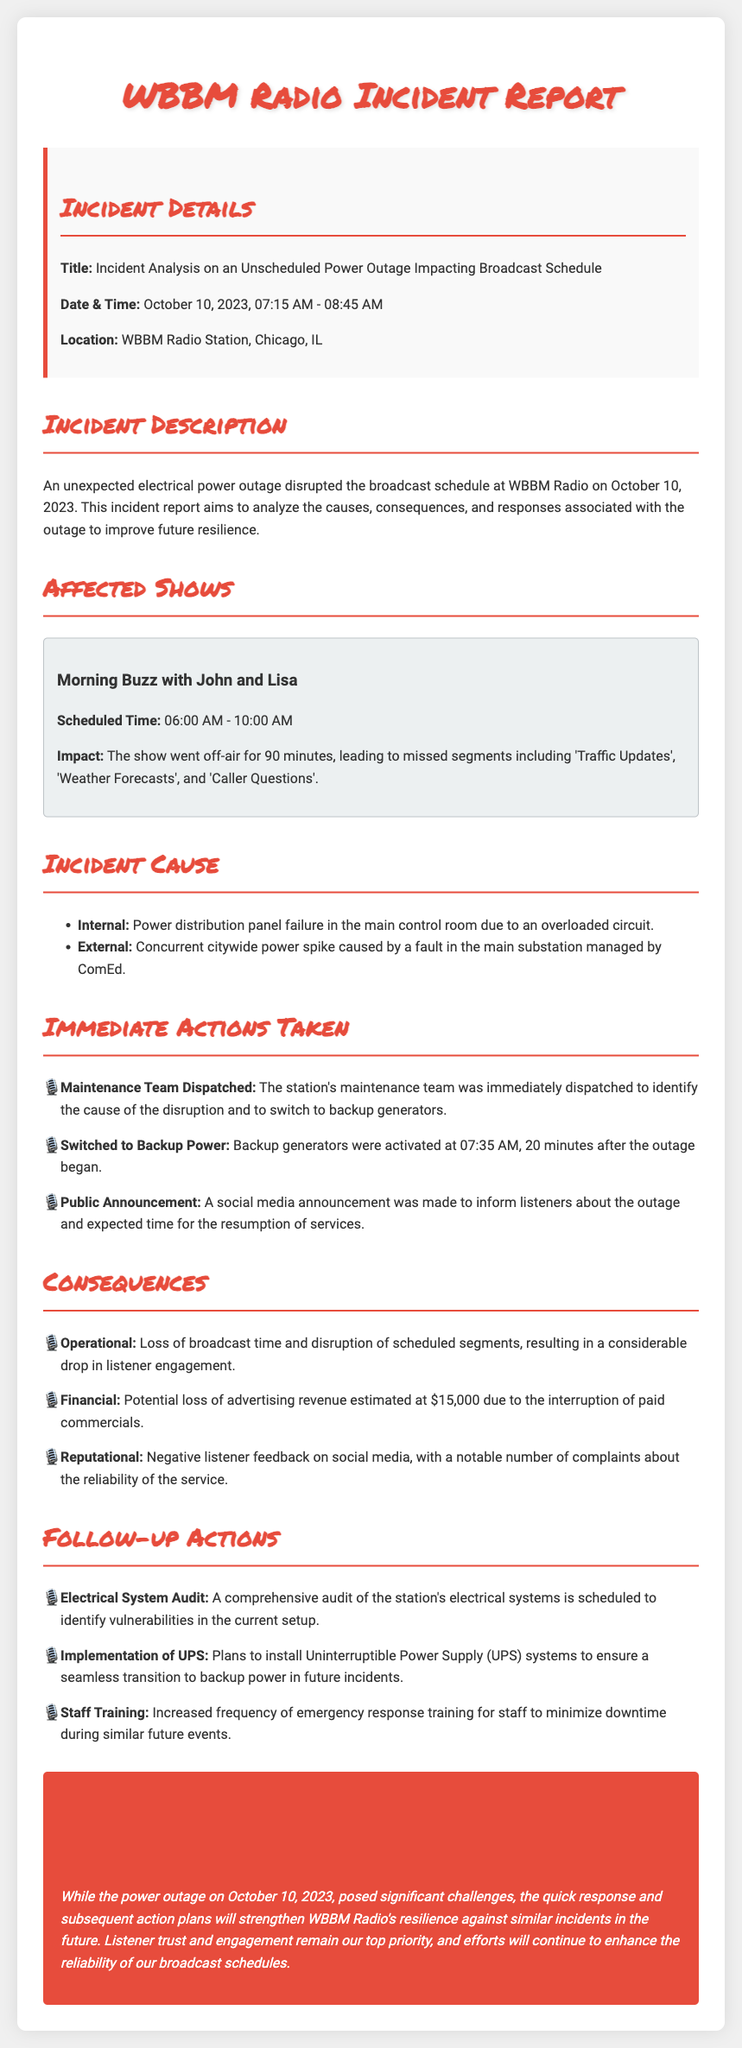What was the date of the incident? The date of the incident is specified in the incident details section.
Answer: October 10, 2023 What time did the power outage occur? The incident report mentions the time period during which the incident took place.
Answer: 07:15 AM - 08:45 AM Which show was impacted by the outage? The affected shows section lists the specific show that went off-air due to the outage.
Answer: Morning Buzz with John and Lisa What was the potential loss of advertising revenue? The document states the estimated financial loss due to interrupted commercials.
Answer: $15,000 What immediate action was taken after the outage began? The actions taken immediately after the outage is mentioned in the immediate actions section.
Answer: Maintenance Team Dispatched What caused the power outage? The incident cause section provides details on both internal and external causes.
Answer: Power distribution panel failure What was one of the follow-up actions planned? The follow-up actions section lists measures to be taken after the incident.
Answer: Electrical System Audit What was the consequence of the power outage regarding listener feedback? The consequences section describes the feedback from listeners after the outage.
Answer: Negative listener feedback on social media What type of system is planned for installation to prevent future issues? The follow-up actions mention this particular system planned for installation.
Answer: Uninterruptible Power Supply (UPS) systems 